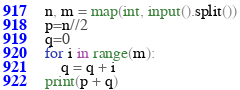<code> <loc_0><loc_0><loc_500><loc_500><_Python_>n, m = map(int, input().split())
p=n//2
q=0
for i in range(m):
    q = q + i
print(p + q)</code> 